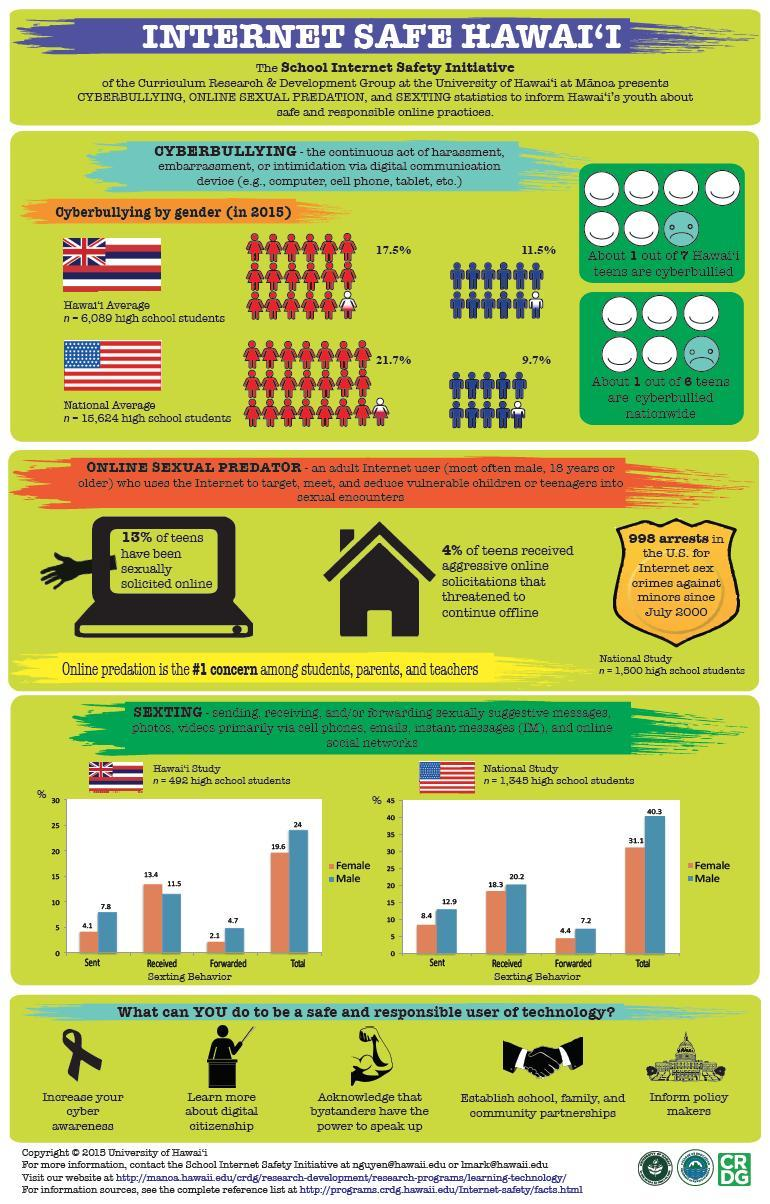What is the percentage difference in girls and boys being cyber bullied in Hawaii?
Answer the question with a short phrase. 6% What was the percentage of boys forwarding sexts in the US, 12.9%, 20.2%, or 7.2%? 7.2% What is the percentage difference in girls and boys being cyber bullied in the US? 12% What was the percentage of girls receiving sexts in Hawaii, 4.1%, 13.4%, or 2.1%? 13.4% 